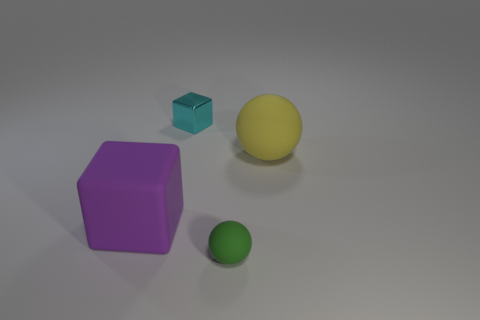Add 2 gray matte objects. How many objects exist? 6 Subtract 1 green spheres. How many objects are left? 3 Subtract all cyan metallic objects. Subtract all big objects. How many objects are left? 1 Add 3 green spheres. How many green spheres are left? 4 Add 3 tiny gray matte cylinders. How many tiny gray matte cylinders exist? 3 